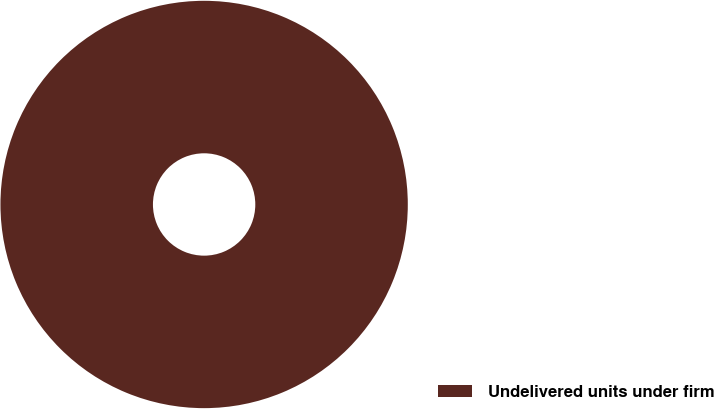<chart> <loc_0><loc_0><loc_500><loc_500><pie_chart><fcel>Undelivered units under firm<nl><fcel>100.0%<nl></chart> 